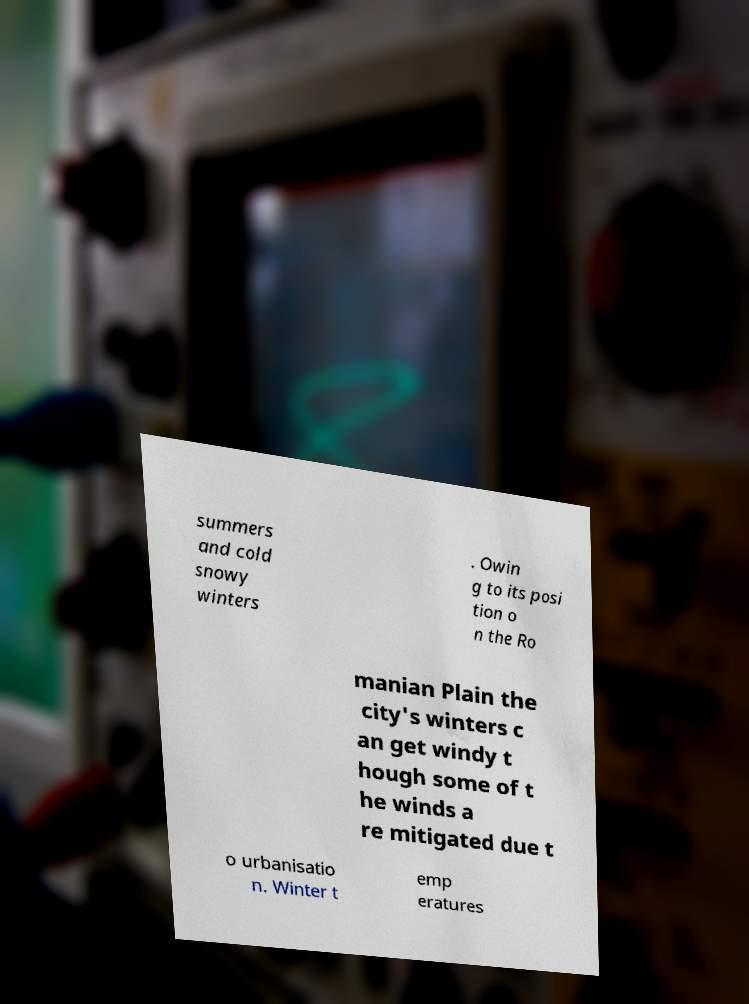Could you extract and type out the text from this image? summers and cold snowy winters . Owin g to its posi tion o n the Ro manian Plain the city's winters c an get windy t hough some of t he winds a re mitigated due t o urbanisatio n. Winter t emp eratures 